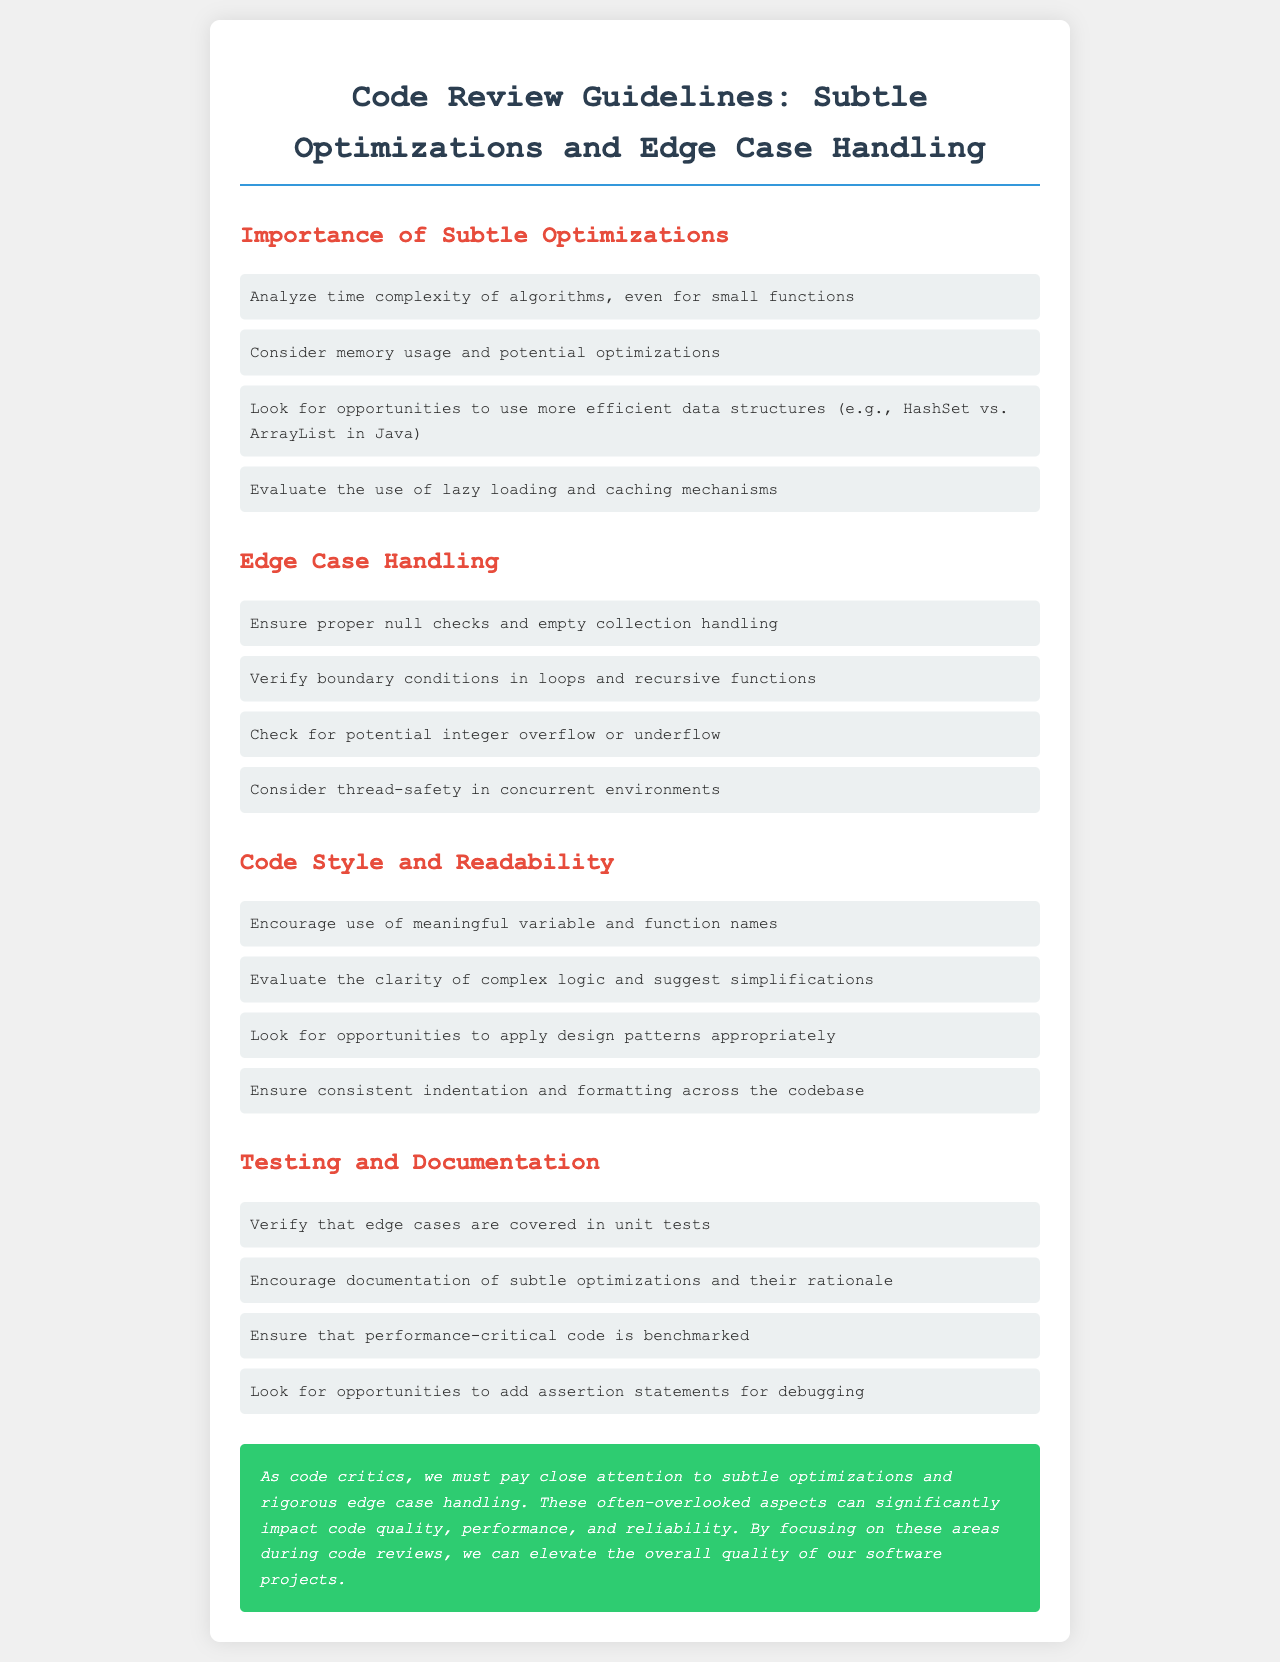What is the title of the document? The title is explicitly stated in the document's header section.
Answer: Code Review Guidelines: Subtle Optimizations and Edge Case Handling What is the first item listed under "Importance of Subtle Optimizations"? The items under the headers are listed in a specific order in the document.
Answer: Analyze time complexity of algorithms, even for small functions How many subsections are listed under "Edge Case Handling"? The number of items listed is easily countable in the provided section.
Answer: Four What color is the conclusion box? The color of the conclusion box is described in the document's style section.
Answer: Green What should be covered in unit tests according to the document? The document states specific practices regarding testing, which can be directly referenced.
Answer: Edge cases What is emphasized as critical in both "Testing and Documentation" and "Edge Case Handling"? Relevant practices from both sections indicate a common theme which must be identified.
Answer: Edge cases What is the suggested naming convention for variables and functions? The document explicitly states preferences for naming conventions under a specific subsection.
Answer: Meaningful How should complex logic be treated according to the guidelines? The document provides guidance on code clarity, specifically regarding complex logic.
Answer: Suggest simplifications What effect does the conclusion indicate subtle optimizations and rigorous edge case handling can have? Document concisely summarizes the impact of the discussed practices in the conclusion.
Answer: Impact code quality, performance, and reliability 